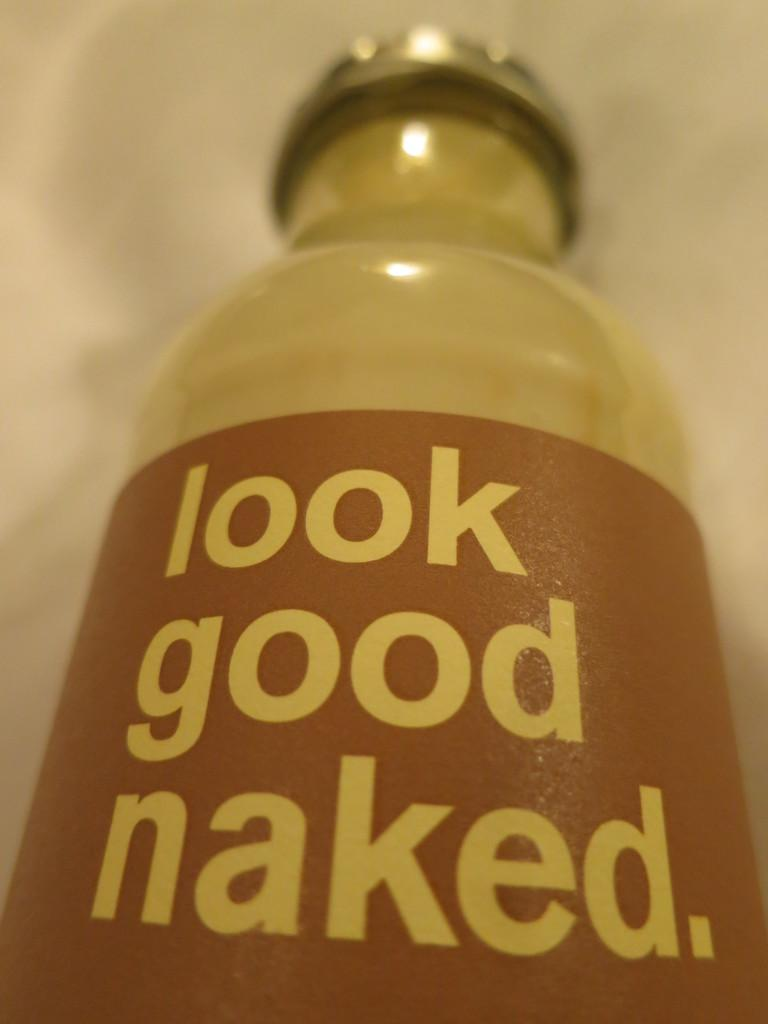Provide a one-sentence caption for the provided image. A bottle of liquid advertises that one should look good naked. 